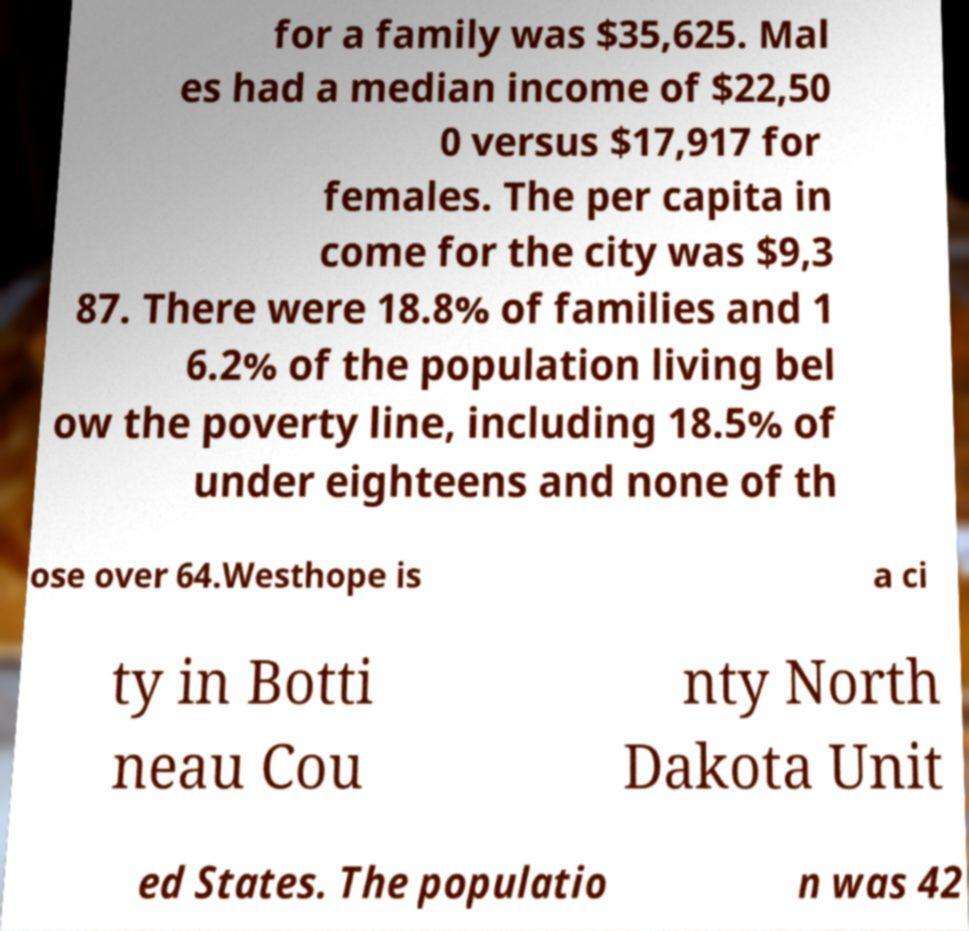Can you read and provide the text displayed in the image?This photo seems to have some interesting text. Can you extract and type it out for me? for a family was $35,625. Mal es had a median income of $22,50 0 versus $17,917 for females. The per capita in come for the city was $9,3 87. There were 18.8% of families and 1 6.2% of the population living bel ow the poverty line, including 18.5% of under eighteens and none of th ose over 64.Westhope is a ci ty in Botti neau Cou nty North Dakota Unit ed States. The populatio n was 42 